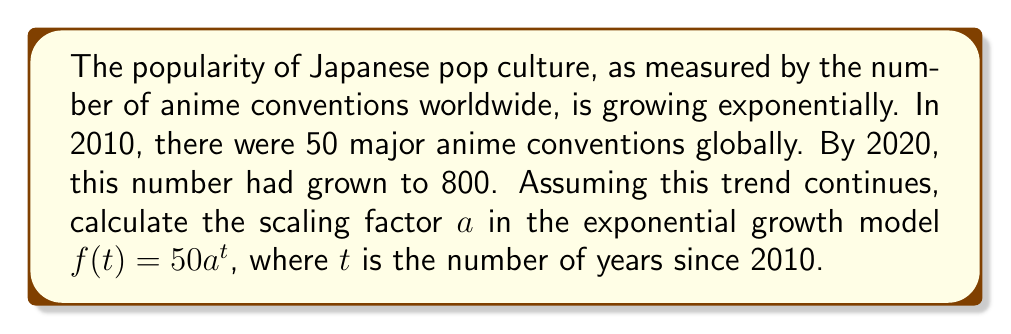Solve this math problem. To solve this problem, we'll follow these steps:

1) The exponential growth model is given by $f(t) = 50a^t$, where:
   - 50 is the initial number of conventions in 2010
   - $a$ is the scaling factor we need to find
   - $t$ is the number of years since 2010

2) We know that in 2020 (10 years after 2010), there were 800 conventions. We can use this information to set up an equation:

   $f(10) = 800$

3) Substituting this into our model:

   $50a^{10} = 800$

4) Divide both sides by 50:

   $a^{10} = \frac{800}{50} = 16$

5) To solve for $a$, we need to take the 10th root of both sides:

   $a = \sqrt[10]{16}$

6) This can be rewritten as:

   $a = 16^{\frac{1}{10}}$

7) Using a calculator or computer, we can evaluate this:

   $a \approx 1.2589$

This means the number of conventions is increasing by approximately 25.89% each year.
Answer: $a \approx 1.2589$ 